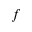Convert formula to latex. <formula><loc_0><loc_0><loc_500><loc_500>f</formula> 